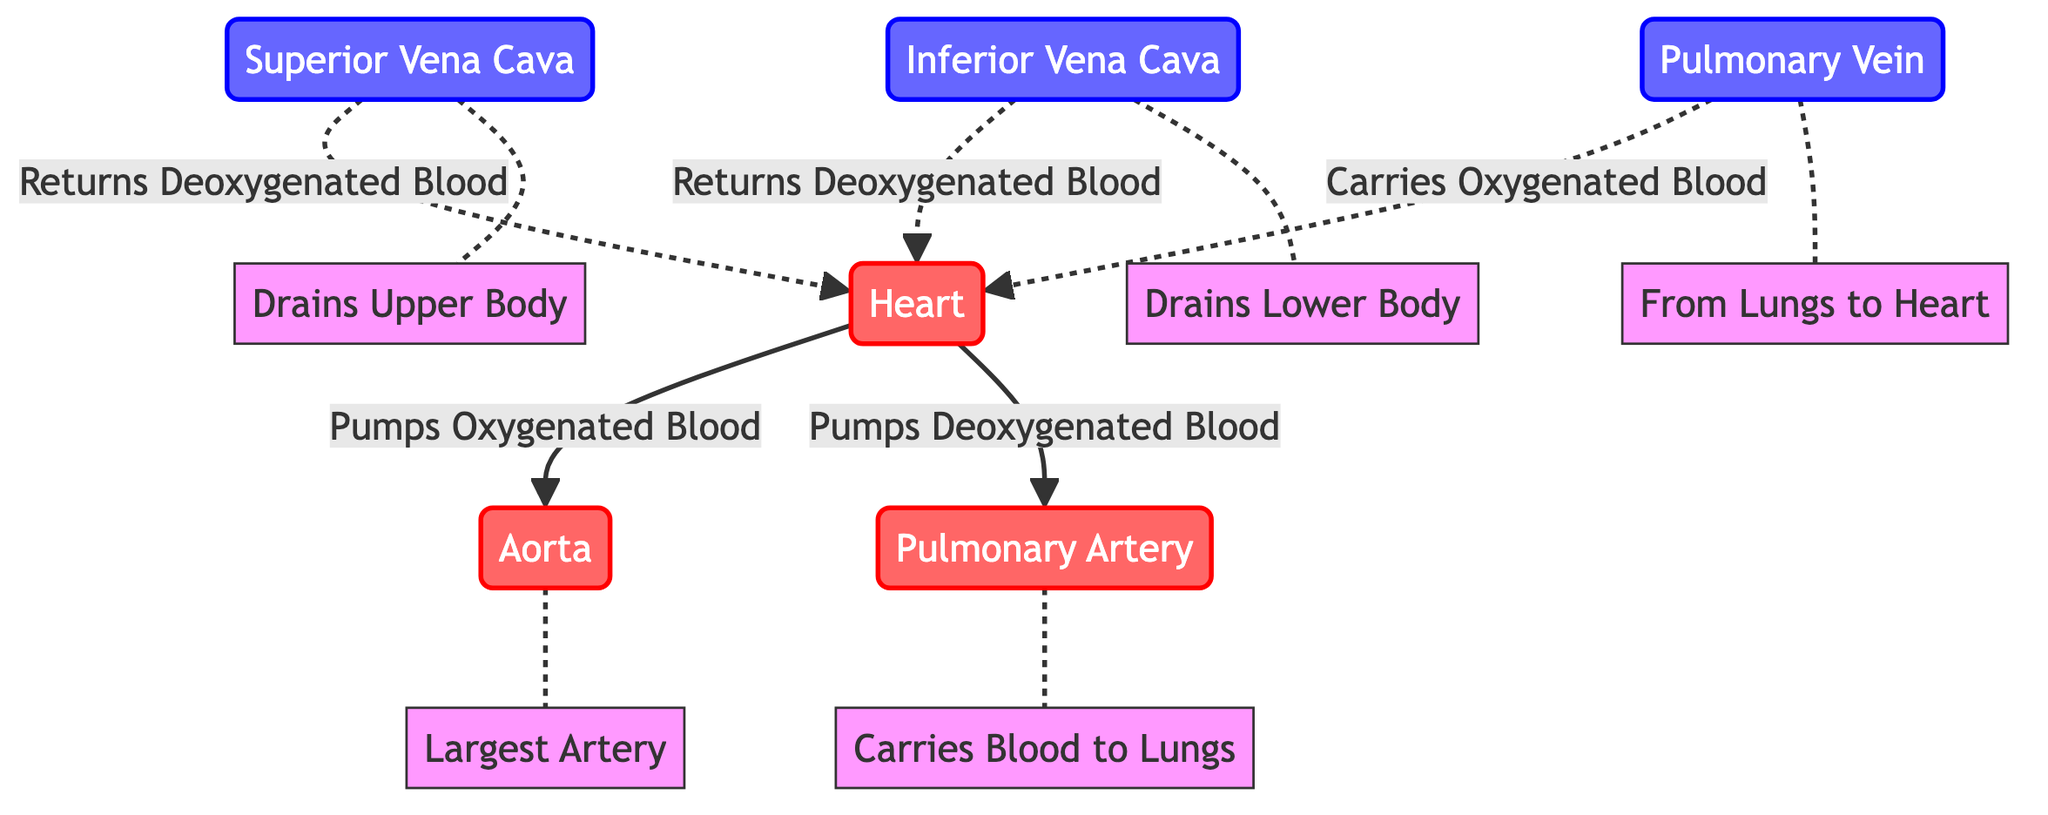what is the color representing the heart in the diagram? The heart is represented by a red color, as indicated by the class definition applied to the heart node. In the provided code, the heart is styled with redNode which fills the color with a shade of red.
Answer: red how many major blood vessels are included in the diagram? The diagram includes a total of five major blood vessels: Aorta, Pulmonary Artery, Superior Vena Cava, Inferior Vena Cava, and Pulmonary Vein. Each of these is distinctly labeled in the diagram, allowing for easy identification.
Answer: five which vein drains the upper body? The Superior Vena Cava drains the upper body as illustrated in the diagram with a dotted connection to the heart. The text annotation specifies its function and confirms its identity.
Answer: Superior Vena Cava what type of blood does the pulmonary artery carry? The pulmonary artery carries deoxygenated blood, as indicated by the directional flow from the heart to the pulmonary artery labeled with "Pumps Deoxygenated Blood".
Answer: Deoxygenated Blood what is the relationship between the aorta and the heart? The relationship between the aorta and the heart is that the heart pumps oxygenated blood into the aorta, as shown by the solid line labeled "Pumps Oxygenated Blood". This indicates a direct flow of blood from the heart to the aorta.
Answer: Pumps Oxygenated Blood how does the inferior vena cava return blood to the heart, and what is its blood type? The inferior vena cava returns deoxygenated blood to the heart, as represented by a dotted line. This is confirmed by the connection from the inferior vena cava to the heart labeled "Returns Deoxygenated Blood".
Answer: Returns Deoxygenated Blood which artery is the largest and what is its specific annotation? The largest artery in the diagram is the Aorta, specifically annotated with "Largest Artery" in the diagram. The aorta is further highlighted with class definitions indicating its importance in the circulatory system.
Answer: Largest Artery which blood vessel is responsible for carrying blood from the lungs to the heart? The Pulmonary Vein is responsible for carrying oxygenated blood from the lungs to the heart, as shown in the diagram where it connects to the heart with a dotted line labeled "Carries Oxygenated Blood".
Answer: Pulmonary Vein 